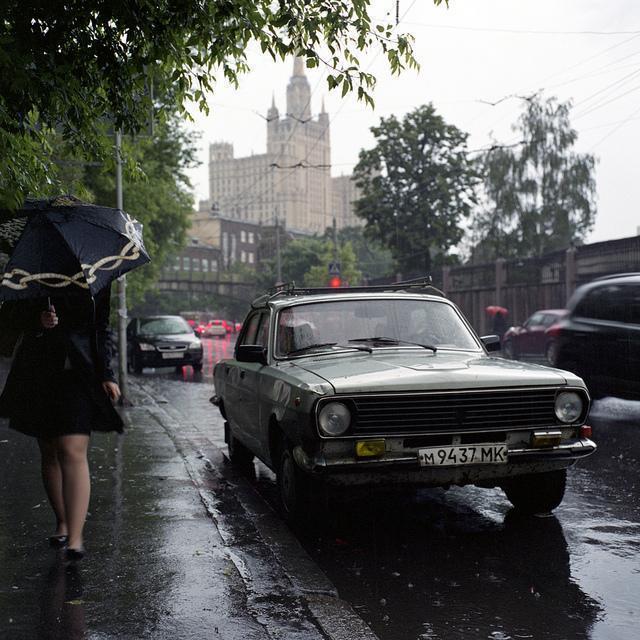What is the danger faced by the woman on the left?
Choose the correct response, then elucidate: 'Answer: answer
Rationale: rationale.'
Options: Getting hit, tornado, getting sunburned, getting splashed. Answer: getting splashed.
Rationale: It is a visibly wet day and the woman is walking in close enough proximity to the street where answer a could be possible from a passing vehicle. 